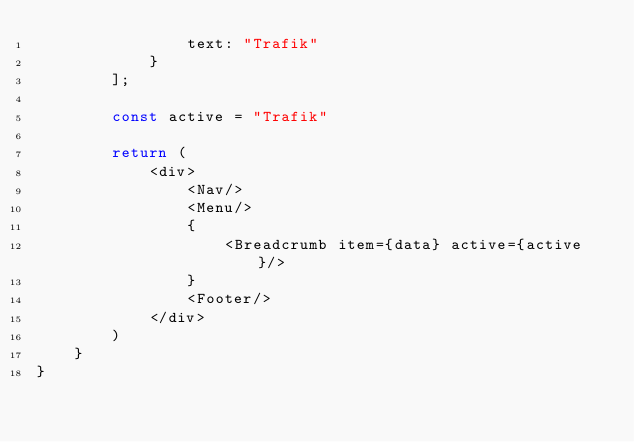<code> <loc_0><loc_0><loc_500><loc_500><_JavaScript_>                text: "Trafik"
            }
        ];

        const active = "Trafik"

        return (
            <div>
                <Nav/>
                <Menu/>
                {
                    <Breadcrumb item={data} active={active}/>
                }
                <Footer/>
            </div>
        )
    }
}</code> 